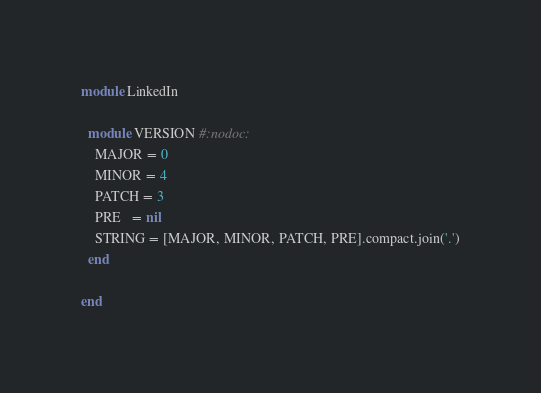<code> <loc_0><loc_0><loc_500><loc_500><_Ruby_>module LinkedIn

  module VERSION #:nodoc:
    MAJOR = 0
    MINOR = 4
    PATCH = 3
    PRE   = nil
    STRING = [MAJOR, MINOR, PATCH, PRE].compact.join('.')
  end

end
</code> 